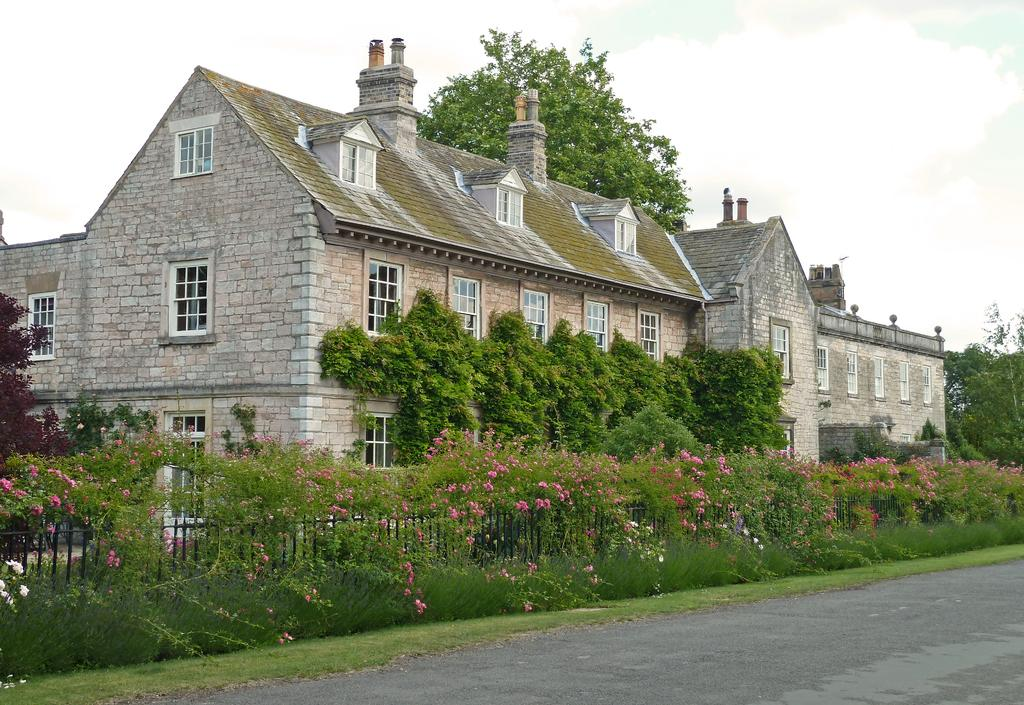How many homes can be seen in the image? There are two homes in the image. What type of vegetation is present in the image? There are green color plants and trees in the image. What kind of barrier can be seen in the image? There is a fencing in the image. What is visible at the top of the image? The sky is visible at the top of the image. Who is the minister in the image? There is no minister present in the image. What type of juice is being served in the image? There is no juice present in the image. 